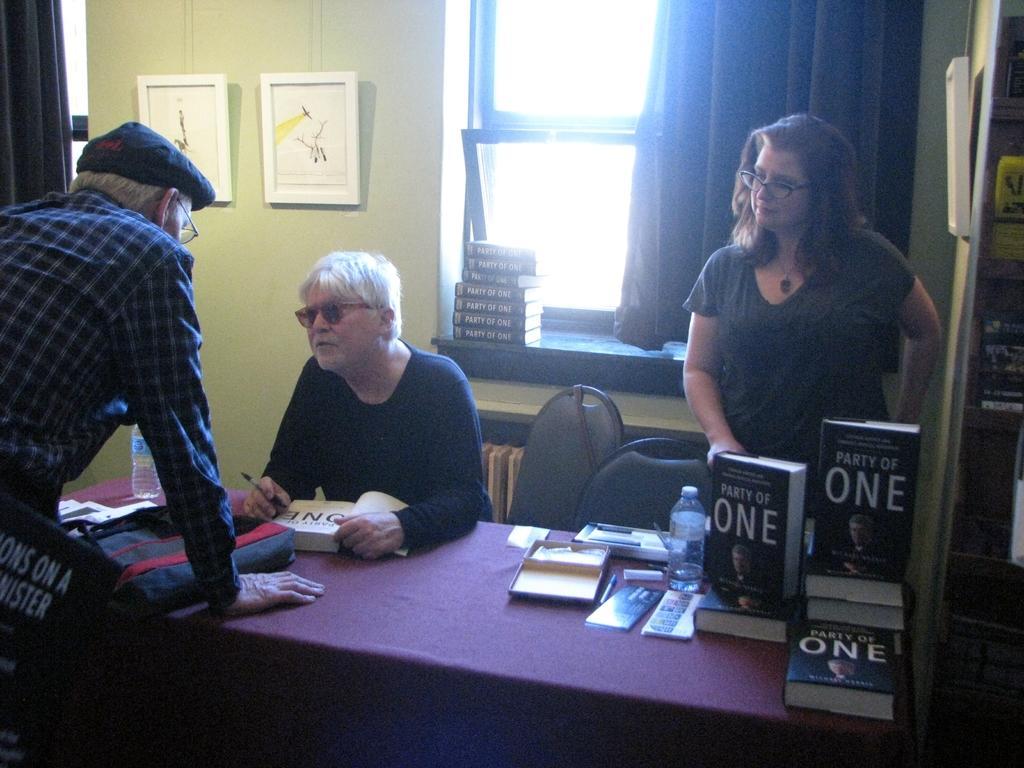In one or two sentences, can you explain what this image depicts? In the picture we can see three people one person is sitting on a chair and one woman is standing near the table and one man is also standing opposite to them near the table, in the background we can see a wall with two photo frames and window with curtain and glasses, near the window there are books and on the table we can also find some books and bottles, pens. 